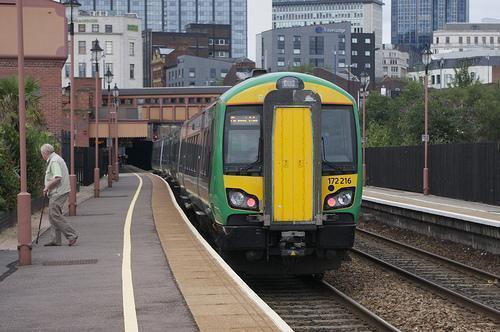How many train tracks are there?
Give a very brief answer. 2. 